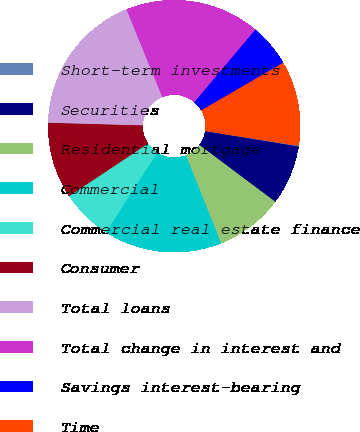Convert chart to OTSL. <chart><loc_0><loc_0><loc_500><loc_500><pie_chart><fcel>Short-term investments<fcel>Securities<fcel>Residential mortgage<fcel>Commercial<fcel>Commercial real estate finance<fcel>Consumer<fcel>Total loans<fcel>Total change in interest and<fcel>Savings interest-bearing<fcel>Time<nl><fcel>0.11%<fcel>7.63%<fcel>8.71%<fcel>15.16%<fcel>6.56%<fcel>9.78%<fcel>18.39%<fcel>17.31%<fcel>5.48%<fcel>10.86%<nl></chart> 